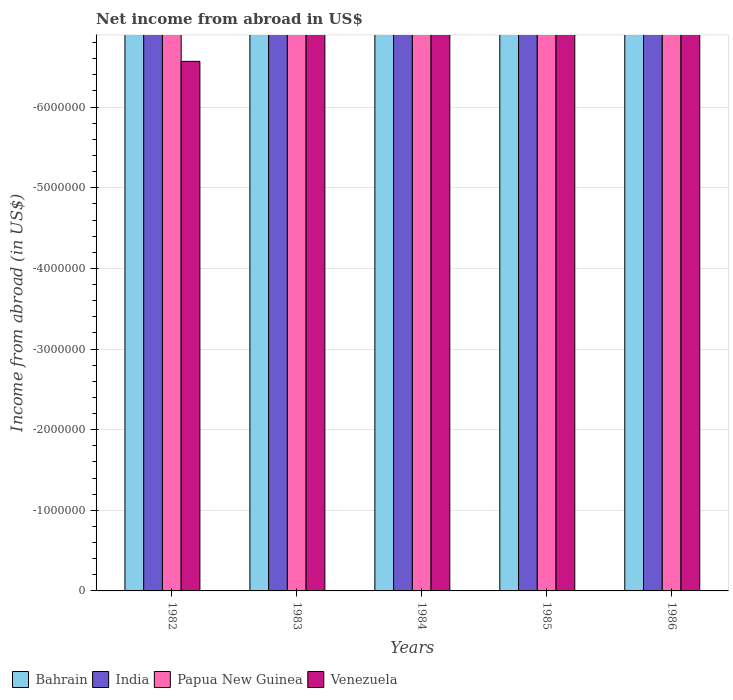How many different coloured bars are there?
Ensure brevity in your answer.  0. Are the number of bars per tick equal to the number of legend labels?
Keep it short and to the point. No. Are the number of bars on each tick of the X-axis equal?
Your answer should be compact. Yes. How many bars are there on the 1st tick from the left?
Keep it short and to the point. 0. What is the net income from abroad in Bahrain in 1984?
Provide a short and direct response. 0. What is the total net income from abroad in Venezuela in the graph?
Offer a very short reply. 0. What is the average net income from abroad in Bahrain per year?
Provide a succinct answer. 0. In how many years, is the net income from abroad in India greater than the average net income from abroad in India taken over all years?
Provide a short and direct response. 0. Is it the case that in every year, the sum of the net income from abroad in Papua New Guinea and net income from abroad in India is greater than the sum of net income from abroad in Bahrain and net income from abroad in Venezuela?
Ensure brevity in your answer.  No. Are all the bars in the graph horizontal?
Your response must be concise. No. What is the difference between two consecutive major ticks on the Y-axis?
Your answer should be compact. 1.00e+06. How are the legend labels stacked?
Make the answer very short. Horizontal. What is the title of the graph?
Your answer should be compact. Net income from abroad in US$. Does "East Asia (all income levels)" appear as one of the legend labels in the graph?
Make the answer very short. No. What is the label or title of the Y-axis?
Provide a succinct answer. Income from abroad (in US$). What is the Income from abroad (in US$) in Bahrain in 1982?
Your response must be concise. 0. What is the Income from abroad (in US$) of India in 1982?
Provide a short and direct response. 0. What is the Income from abroad (in US$) of Venezuela in 1982?
Offer a very short reply. 0. What is the Income from abroad (in US$) in India in 1983?
Your answer should be compact. 0. What is the Income from abroad (in US$) in India in 1984?
Your answer should be compact. 0. What is the Income from abroad (in US$) in Papua New Guinea in 1984?
Make the answer very short. 0. What is the Income from abroad (in US$) of India in 1985?
Keep it short and to the point. 0. What is the Income from abroad (in US$) in Papua New Guinea in 1985?
Your answer should be very brief. 0. What is the Income from abroad (in US$) in Venezuela in 1985?
Provide a short and direct response. 0. What is the Income from abroad (in US$) in Bahrain in 1986?
Give a very brief answer. 0. What is the Income from abroad (in US$) in India in 1986?
Make the answer very short. 0. What is the Income from abroad (in US$) in Papua New Guinea in 1986?
Provide a succinct answer. 0. What is the Income from abroad (in US$) of Venezuela in 1986?
Make the answer very short. 0. What is the total Income from abroad (in US$) of India in the graph?
Offer a terse response. 0. What is the total Income from abroad (in US$) of Papua New Guinea in the graph?
Offer a very short reply. 0. What is the average Income from abroad (in US$) in Bahrain per year?
Give a very brief answer. 0. What is the average Income from abroad (in US$) of Papua New Guinea per year?
Make the answer very short. 0. What is the average Income from abroad (in US$) of Venezuela per year?
Give a very brief answer. 0. 